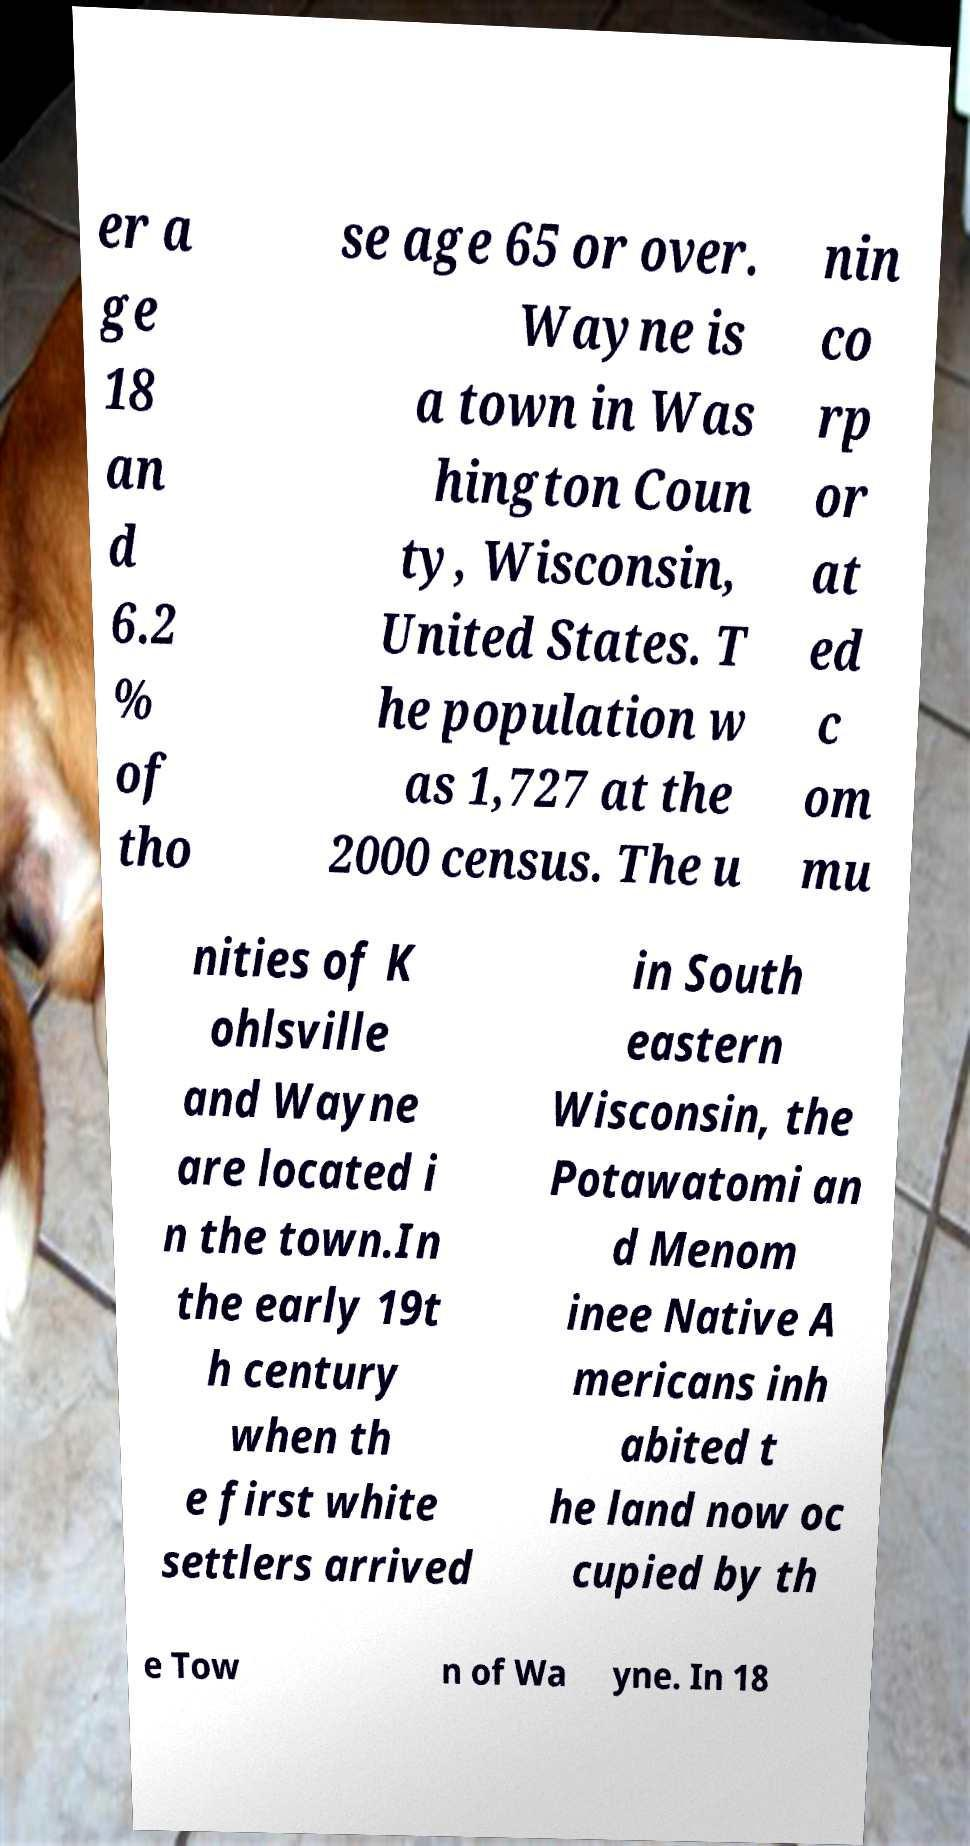I need the written content from this picture converted into text. Can you do that? er a ge 18 an d 6.2 % of tho se age 65 or over. Wayne is a town in Was hington Coun ty, Wisconsin, United States. T he population w as 1,727 at the 2000 census. The u nin co rp or at ed c om mu nities of K ohlsville and Wayne are located i n the town.In the early 19t h century when th e first white settlers arrived in South eastern Wisconsin, the Potawatomi an d Menom inee Native A mericans inh abited t he land now oc cupied by th e Tow n of Wa yne. In 18 